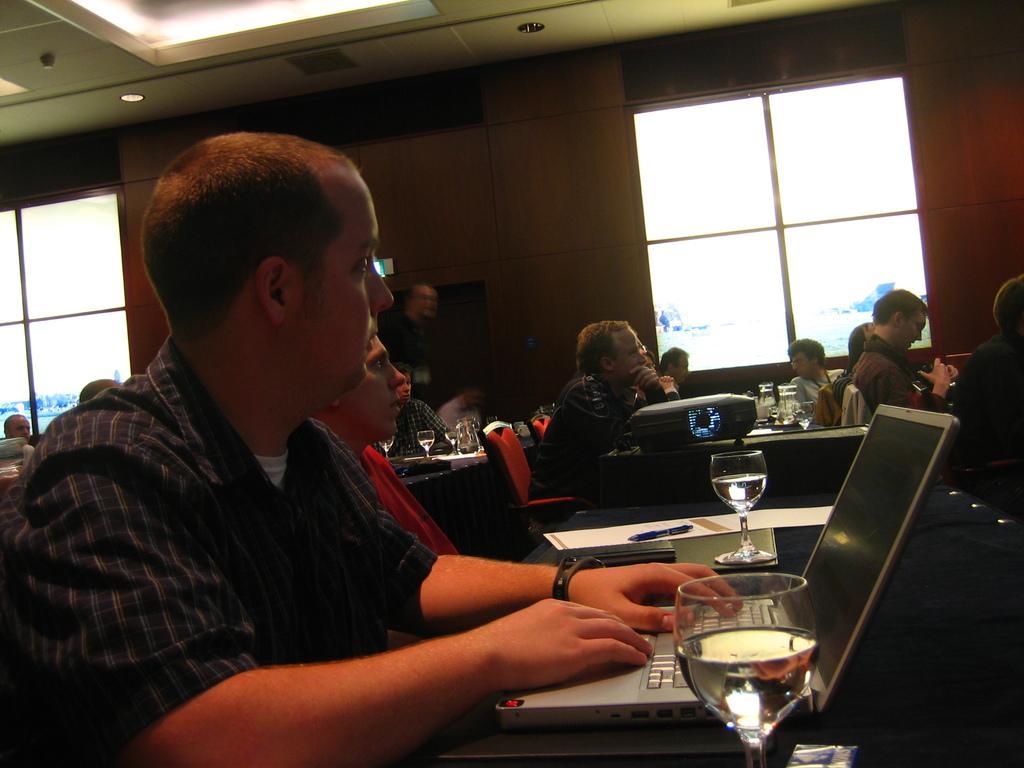In one or two sentences, can you explain what this image depicts? In this image we can see many people sitting. There are tables. On the table there are glasses, laptop, paper, pen and many other items. In the back there is a wall. Also there are windows. On the ceiling there are lights. 